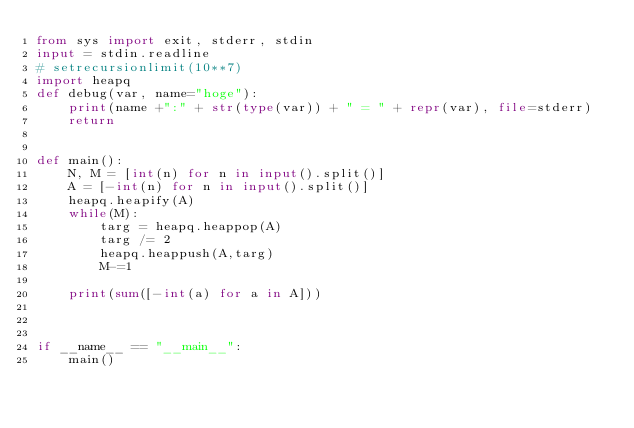Convert code to text. <code><loc_0><loc_0><loc_500><loc_500><_Python_>from sys import exit, stderr, stdin
input = stdin.readline
# setrecursionlimit(10**7)
import heapq
def debug(var, name="hoge"):
    print(name +":" + str(type(var)) + " = " + repr(var), file=stderr)
    return


def main():
    N, M = [int(n) for n in input().split()]
    A = [-int(n) for n in input().split()]
    heapq.heapify(A)
    while(M):
        targ = heapq.heappop(A)
        targ /= 2
        heapq.heappush(A,targ)
        M-=1

    print(sum([-int(a) for a in A]))



if __name__ == "__main__":
    main()
</code> 